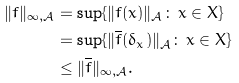<formula> <loc_0><loc_0><loc_500><loc_500>\| f \| _ { \infty , \mathcal { A } } & = \sup \{ \| f ( x ) \| _ { \mathcal { A } } \colon \, x \in X \} \\ & = \sup \{ \| \overline { f } ( \delta _ { x } ) \| _ { \mathcal { A } } \colon \, x \in X \} \\ & \leq \| \overline { f } \| _ { \infty , \mathcal { A } } .</formula> 